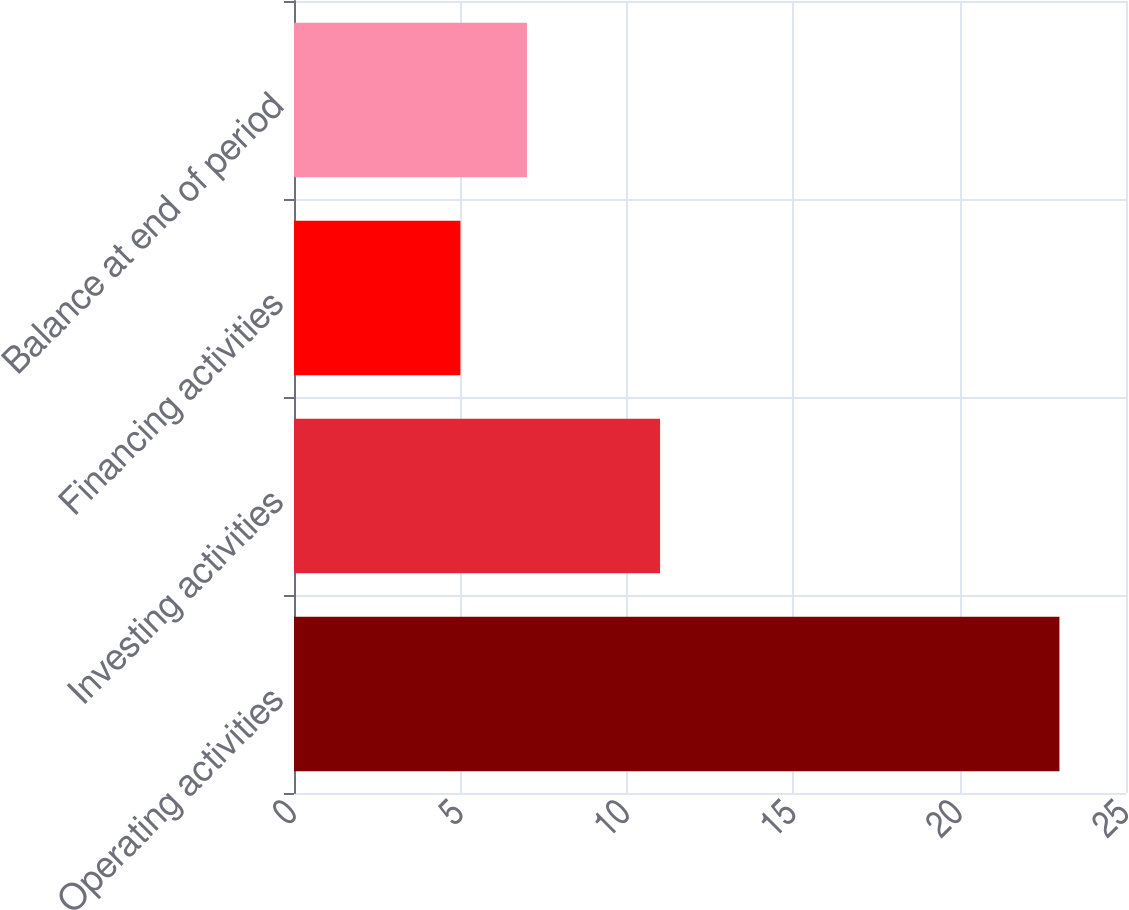Convert chart. <chart><loc_0><loc_0><loc_500><loc_500><bar_chart><fcel>Operating activities<fcel>Investing activities<fcel>Financing activities<fcel>Balance at end of period<nl><fcel>23<fcel>11<fcel>5<fcel>7<nl></chart> 